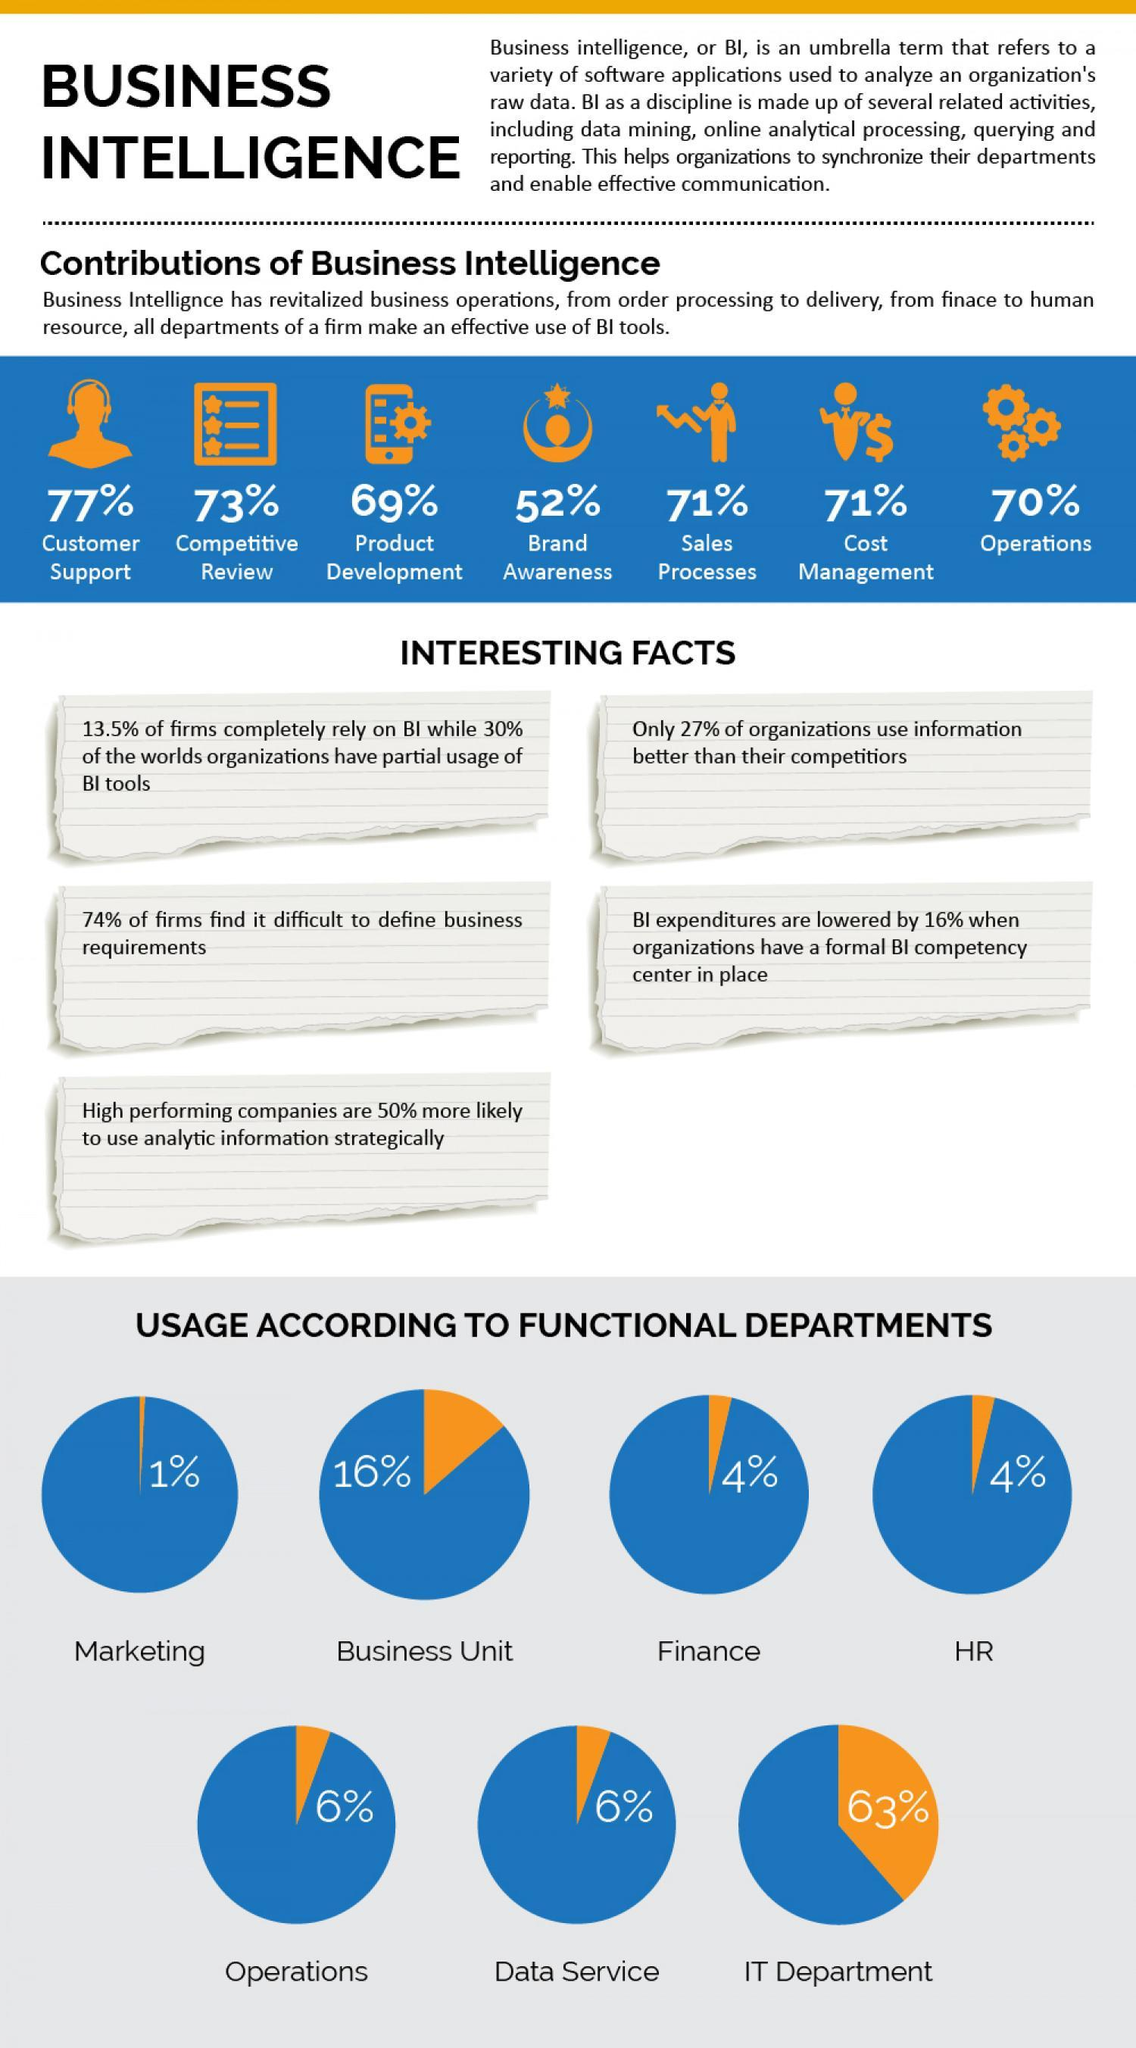in which area has the contribution of BI been second lowest
Answer the question with a short phrase. Product development In which area has the contribution of BI been the same as sales processes Cost management Which functional departments have 6% usage of BI Operations, Data Service Which functional department has the same usage of BI as Finance HR what happens to an organisation when a formal BI competency center is in place BI expenditure are lowered by 16% 